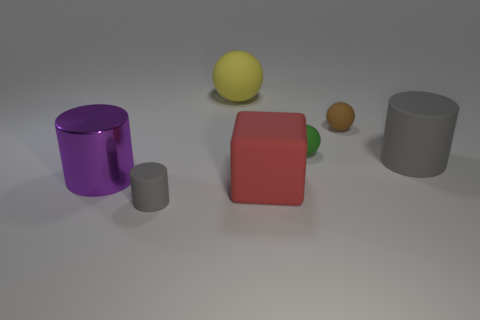How big is the thing that is behind the tiny green thing and on the right side of the cube?
Offer a very short reply. Small. How many big cylinders have the same material as the red object?
Your answer should be very brief. 1. What number of blocks are small yellow things or rubber objects?
Offer a very short reply. 1. There is a gray rubber thing that is on the left side of the big matte thing that is in front of the gray object that is behind the large metal cylinder; what is its size?
Offer a very short reply. Small. The matte object that is both to the right of the tiny green rubber object and left of the big gray rubber cylinder is what color?
Ensure brevity in your answer.  Brown. There is a metallic cylinder; does it have the same size as the gray cylinder that is in front of the large shiny object?
Make the answer very short. No. Is there anything else that is the same shape as the large red thing?
Offer a very short reply. No. What is the color of the large shiny thing that is the same shape as the tiny gray rubber thing?
Your answer should be very brief. Purple. Does the red thing have the same size as the shiny cylinder?
Your answer should be compact. Yes. What number of other objects are there of the same size as the green thing?
Offer a terse response. 2. 